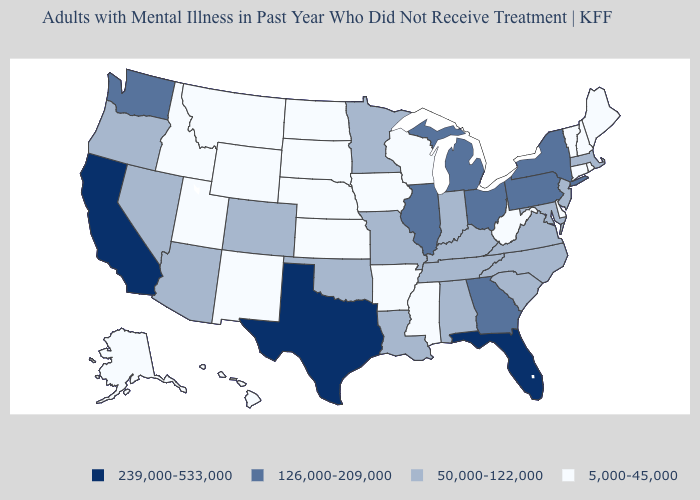Name the states that have a value in the range 239,000-533,000?
Be succinct. California, Florida, Texas. Which states have the lowest value in the West?
Keep it brief. Alaska, Hawaii, Idaho, Montana, New Mexico, Utah, Wyoming. Which states hav the highest value in the West?
Keep it brief. California. Name the states that have a value in the range 50,000-122,000?
Write a very short answer. Alabama, Arizona, Colorado, Indiana, Kentucky, Louisiana, Maryland, Massachusetts, Minnesota, Missouri, Nevada, New Jersey, North Carolina, Oklahoma, Oregon, South Carolina, Tennessee, Virginia. Which states have the lowest value in the South?
Give a very brief answer. Arkansas, Delaware, Mississippi, West Virginia. Does Alabama have a lower value than Tennessee?
Short answer required. No. Which states have the highest value in the USA?
Be succinct. California, Florida, Texas. Name the states that have a value in the range 239,000-533,000?
Keep it brief. California, Florida, Texas. What is the value of Colorado?
Give a very brief answer. 50,000-122,000. Name the states that have a value in the range 50,000-122,000?
Give a very brief answer. Alabama, Arizona, Colorado, Indiana, Kentucky, Louisiana, Maryland, Massachusetts, Minnesota, Missouri, Nevada, New Jersey, North Carolina, Oklahoma, Oregon, South Carolina, Tennessee, Virginia. Which states have the highest value in the USA?
Answer briefly. California, Florida, Texas. Among the states that border Indiana , does Kentucky have the lowest value?
Be succinct. Yes. Is the legend a continuous bar?
Keep it brief. No. What is the value of Hawaii?
Write a very short answer. 5,000-45,000. What is the value of Oklahoma?
Short answer required. 50,000-122,000. 